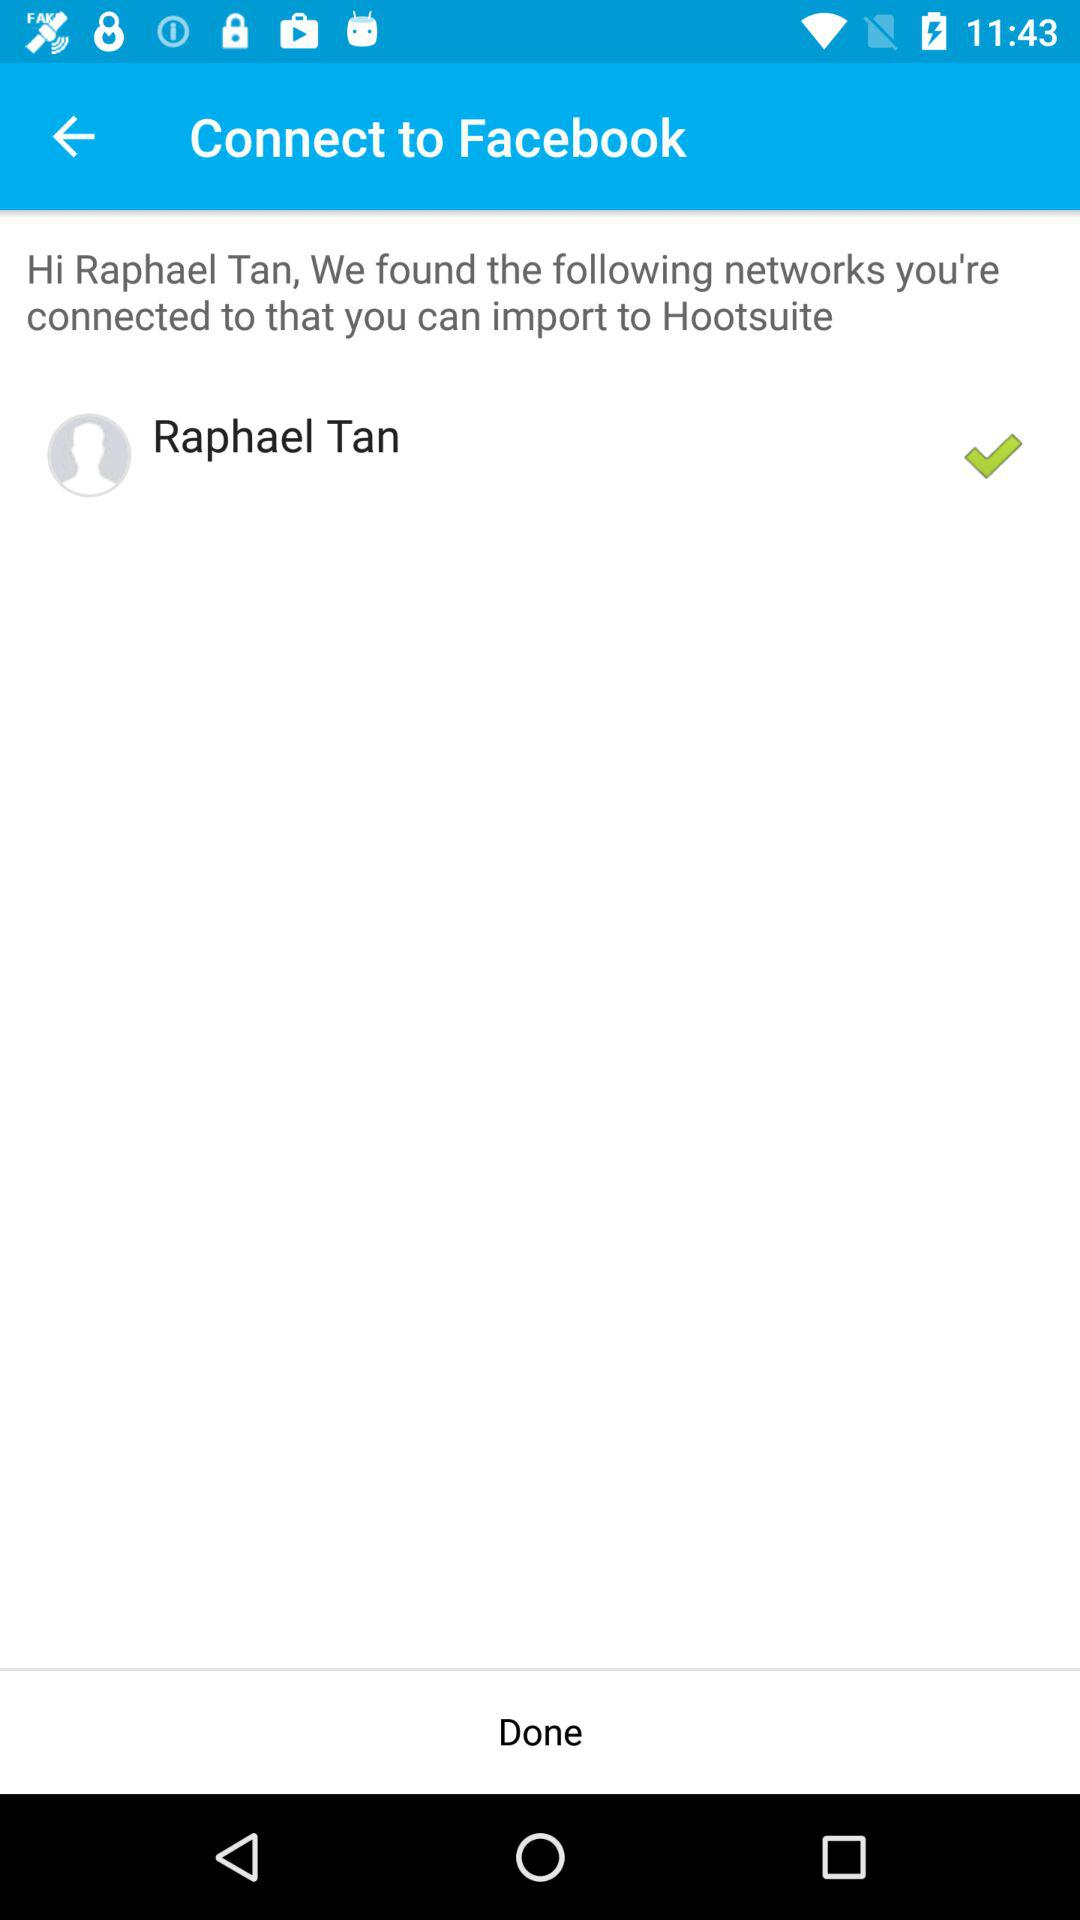What is the user name? The user name is Raphael Tan. 